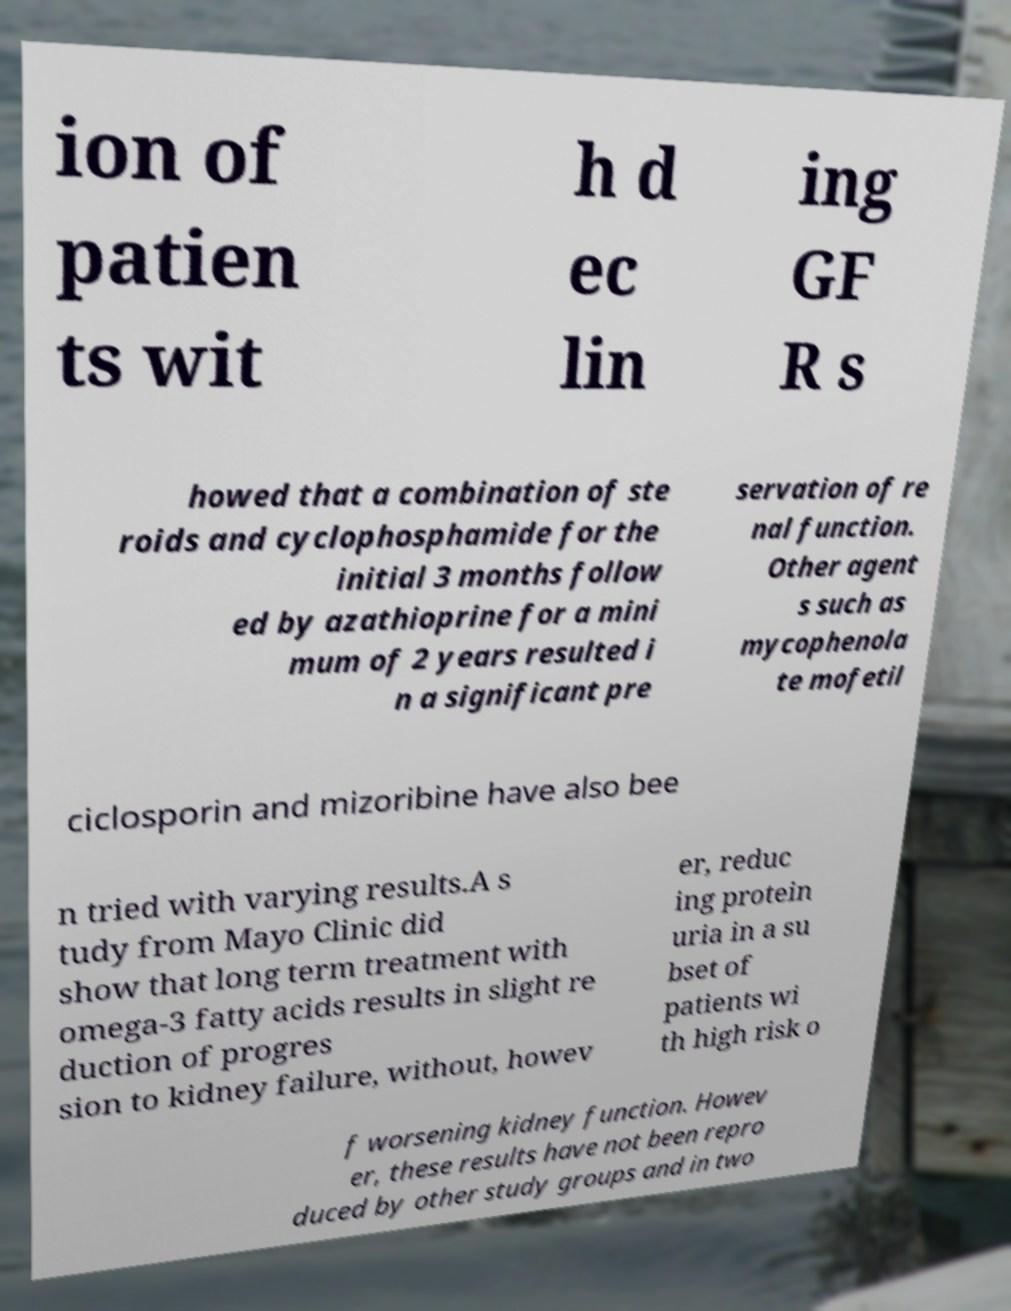There's text embedded in this image that I need extracted. Can you transcribe it verbatim? ion of patien ts wit h d ec lin ing GF R s howed that a combination of ste roids and cyclophosphamide for the initial 3 months follow ed by azathioprine for a mini mum of 2 years resulted i n a significant pre servation of re nal function. Other agent s such as mycophenola te mofetil ciclosporin and mizoribine have also bee n tried with varying results.A s tudy from Mayo Clinic did show that long term treatment with omega-3 fatty acids results in slight re duction of progres sion to kidney failure, without, howev er, reduc ing protein uria in a su bset of patients wi th high risk o f worsening kidney function. Howev er, these results have not been repro duced by other study groups and in two 